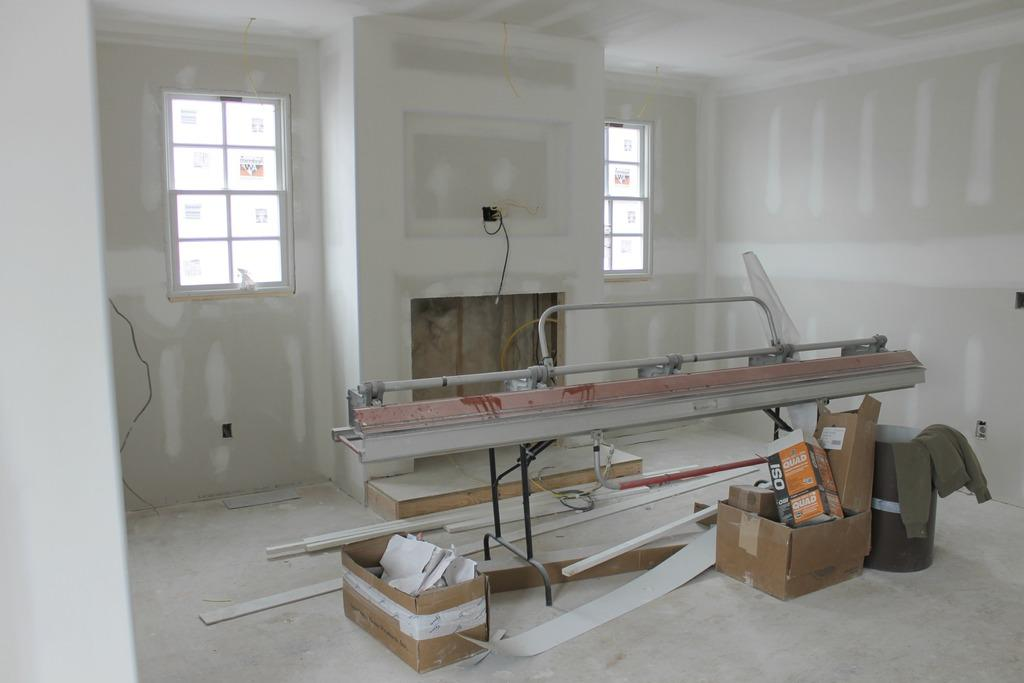What type of view does the image provide? The image shows the inner view of a room. What can be seen on a stand in the room? There is a machine on a stand in the room. What type of containers are present in the room? Cardboard cartons are present in the room. What structural elements can be seen in the room? Wooden bars are visible in the room. What type of clothing item is in the room? A sweater is in the room. What allows natural light to enter the room? There are windows in the room. What connects the machine to a power source? Cables are present in the room. What type of bushes can be seen growing near the windows in the room? There are no bushes visible in the image; it shows the inner view of a room with windows, but no bushes are present. What is the purpose of the sweater in the room? The purpose of the sweater in the room cannot be determined from the image alone, as it could be for various reasons such as storage, display, or personal use. 